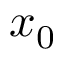Convert formula to latex. <formula><loc_0><loc_0><loc_500><loc_500>x _ { 0 }</formula> 